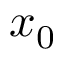Convert formula to latex. <formula><loc_0><loc_0><loc_500><loc_500>x _ { 0 }</formula> 